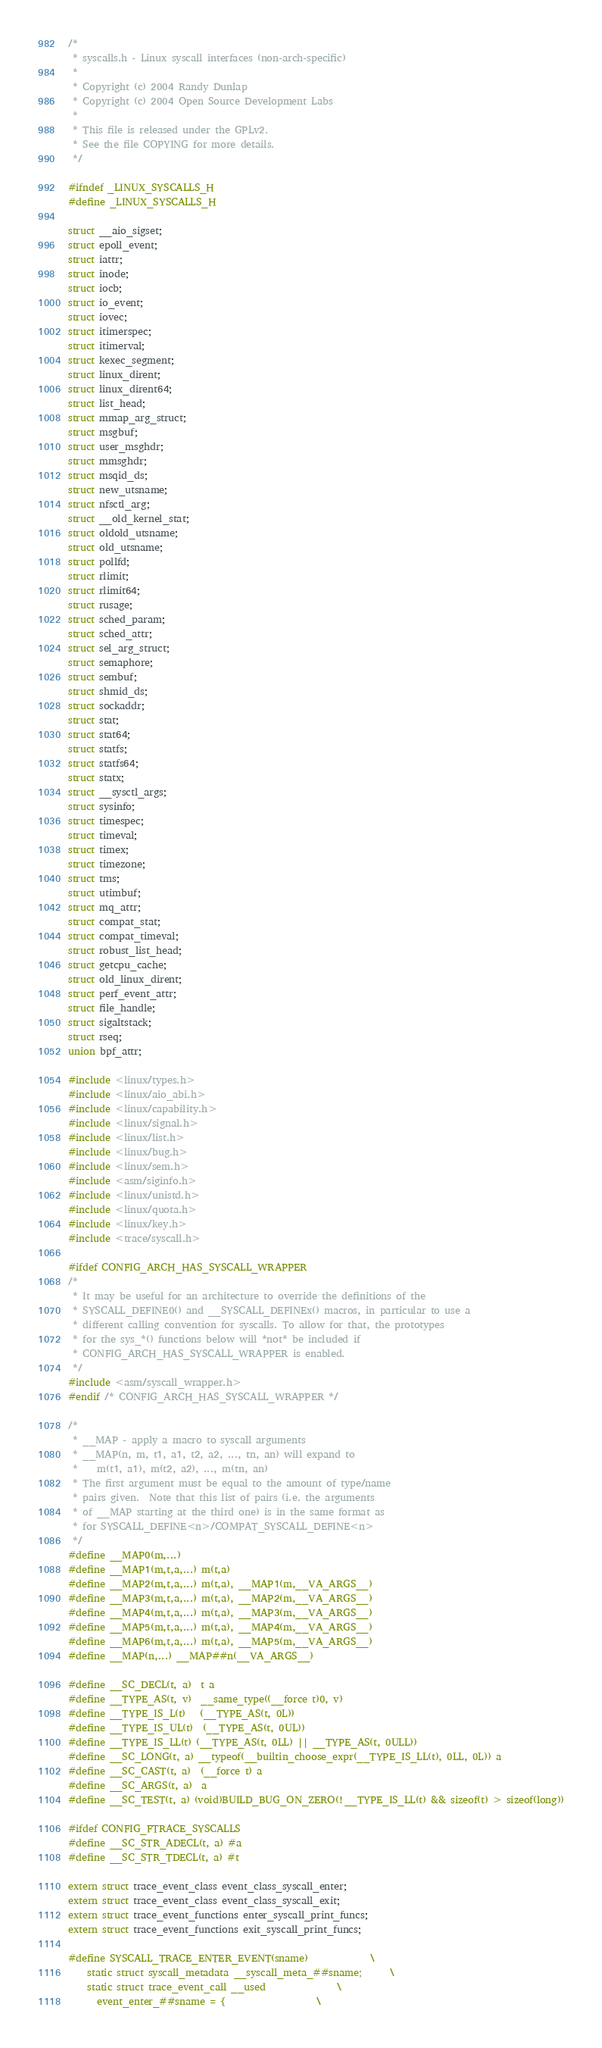Convert code to text. <code><loc_0><loc_0><loc_500><loc_500><_C_>/*
 * syscalls.h - Linux syscall interfaces (non-arch-specific)
 *
 * Copyright (c) 2004 Randy Dunlap
 * Copyright (c) 2004 Open Source Development Labs
 *
 * This file is released under the GPLv2.
 * See the file COPYING for more details.
 */

#ifndef _LINUX_SYSCALLS_H
#define _LINUX_SYSCALLS_H

struct __aio_sigset;
struct epoll_event;
struct iattr;
struct inode;
struct iocb;
struct io_event;
struct iovec;
struct itimerspec;
struct itimerval;
struct kexec_segment;
struct linux_dirent;
struct linux_dirent64;
struct list_head;
struct mmap_arg_struct;
struct msgbuf;
struct user_msghdr;
struct mmsghdr;
struct msqid_ds;
struct new_utsname;
struct nfsctl_arg;
struct __old_kernel_stat;
struct oldold_utsname;
struct old_utsname;
struct pollfd;
struct rlimit;
struct rlimit64;
struct rusage;
struct sched_param;
struct sched_attr;
struct sel_arg_struct;
struct semaphore;
struct sembuf;
struct shmid_ds;
struct sockaddr;
struct stat;
struct stat64;
struct statfs;
struct statfs64;
struct statx;
struct __sysctl_args;
struct sysinfo;
struct timespec;
struct timeval;
struct timex;
struct timezone;
struct tms;
struct utimbuf;
struct mq_attr;
struct compat_stat;
struct compat_timeval;
struct robust_list_head;
struct getcpu_cache;
struct old_linux_dirent;
struct perf_event_attr;
struct file_handle;
struct sigaltstack;
struct rseq;
union bpf_attr;

#include <linux/types.h>
#include <linux/aio_abi.h>
#include <linux/capability.h>
#include <linux/signal.h>
#include <linux/list.h>
#include <linux/bug.h>
#include <linux/sem.h>
#include <asm/siginfo.h>
#include <linux/unistd.h>
#include <linux/quota.h>
#include <linux/key.h>
#include <trace/syscall.h>

#ifdef CONFIG_ARCH_HAS_SYSCALL_WRAPPER
/*
 * It may be useful for an architecture to override the definitions of the
 * SYSCALL_DEFINE0() and __SYSCALL_DEFINEx() macros, in particular to use a
 * different calling convention for syscalls. To allow for that, the prototypes
 * for the sys_*() functions below will *not* be included if
 * CONFIG_ARCH_HAS_SYSCALL_WRAPPER is enabled.
 */
#include <asm/syscall_wrapper.h>
#endif /* CONFIG_ARCH_HAS_SYSCALL_WRAPPER */

/*
 * __MAP - apply a macro to syscall arguments
 * __MAP(n, m, t1, a1, t2, a2, ..., tn, an) will expand to
 *    m(t1, a1), m(t2, a2), ..., m(tn, an)
 * The first argument must be equal to the amount of type/name
 * pairs given.  Note that this list of pairs (i.e. the arguments
 * of __MAP starting at the third one) is in the same format as
 * for SYSCALL_DEFINE<n>/COMPAT_SYSCALL_DEFINE<n>
 */
#define __MAP0(m,...)
#define __MAP1(m,t,a,...) m(t,a)
#define __MAP2(m,t,a,...) m(t,a), __MAP1(m,__VA_ARGS__)
#define __MAP3(m,t,a,...) m(t,a), __MAP2(m,__VA_ARGS__)
#define __MAP4(m,t,a,...) m(t,a), __MAP3(m,__VA_ARGS__)
#define __MAP5(m,t,a,...) m(t,a), __MAP4(m,__VA_ARGS__)
#define __MAP6(m,t,a,...) m(t,a), __MAP5(m,__VA_ARGS__)
#define __MAP(n,...) __MAP##n(__VA_ARGS__)

#define __SC_DECL(t, a)	t a
#define __TYPE_AS(t, v)	__same_type((__force t)0, v)
#define __TYPE_IS_L(t)	(__TYPE_AS(t, 0L))
#define __TYPE_IS_UL(t)	(__TYPE_AS(t, 0UL))
#define __TYPE_IS_LL(t) (__TYPE_AS(t, 0LL) || __TYPE_AS(t, 0ULL))
#define __SC_LONG(t, a) __typeof(__builtin_choose_expr(__TYPE_IS_LL(t), 0LL, 0L)) a
#define __SC_CAST(t, a)	(__force t) a
#define __SC_ARGS(t, a)	a
#define __SC_TEST(t, a) (void)BUILD_BUG_ON_ZERO(!__TYPE_IS_LL(t) && sizeof(t) > sizeof(long))

#ifdef CONFIG_FTRACE_SYSCALLS
#define __SC_STR_ADECL(t, a)	#a
#define __SC_STR_TDECL(t, a)	#t

extern struct trace_event_class event_class_syscall_enter;
extern struct trace_event_class event_class_syscall_exit;
extern struct trace_event_functions enter_syscall_print_funcs;
extern struct trace_event_functions exit_syscall_print_funcs;

#define SYSCALL_TRACE_ENTER_EVENT(sname)				\
	static struct syscall_metadata __syscall_meta_##sname;		\
	static struct trace_event_call __used				\
	  event_enter_##sname = {					\</code> 